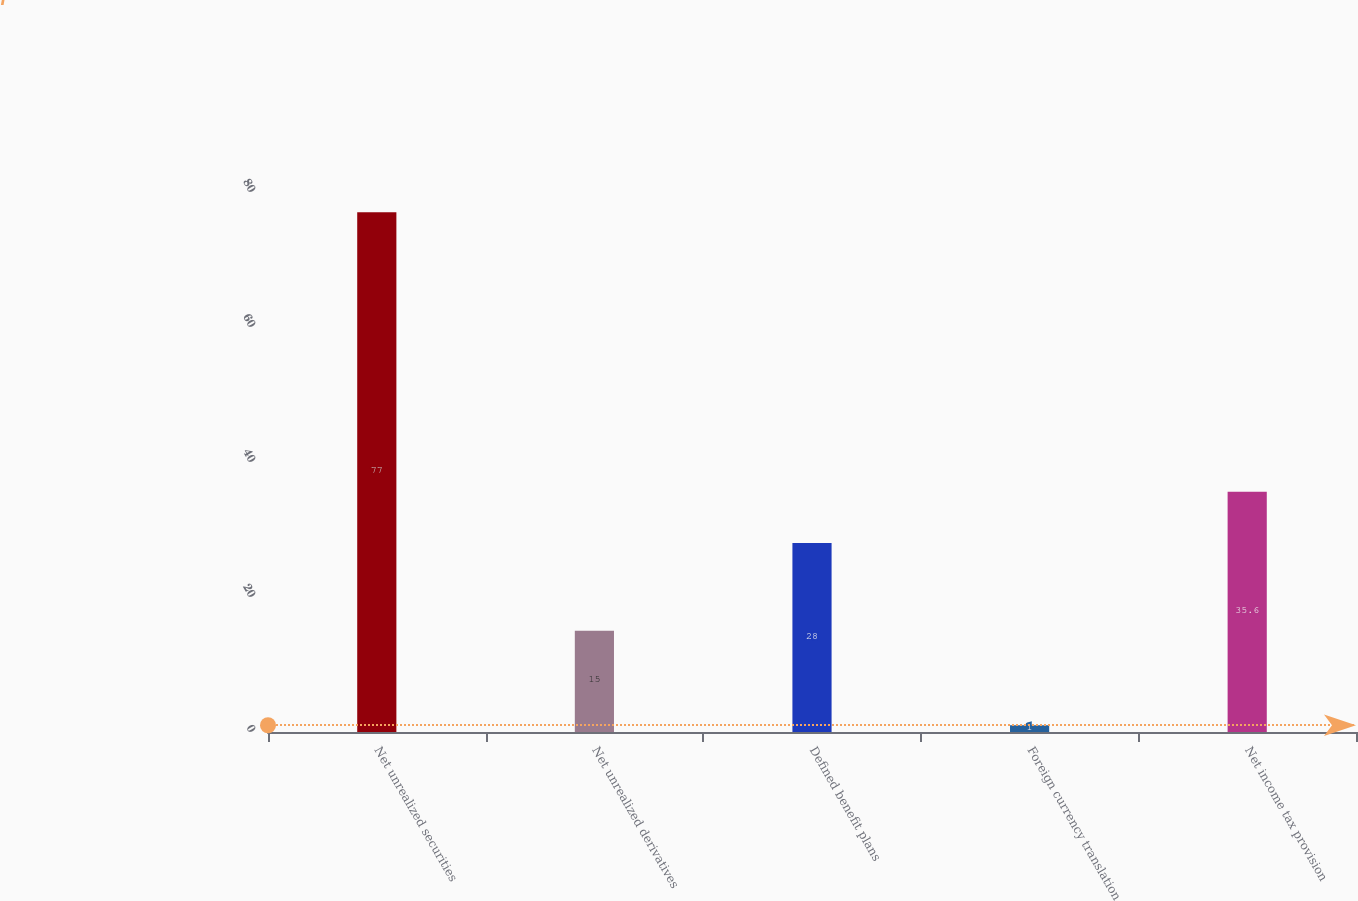Convert chart. <chart><loc_0><loc_0><loc_500><loc_500><bar_chart><fcel>Net unrealized securities<fcel>Net unrealized derivatives<fcel>Defined benefit plans<fcel>Foreign currency translation<fcel>Net income tax provision<nl><fcel>77<fcel>15<fcel>28<fcel>1<fcel>35.6<nl></chart> 